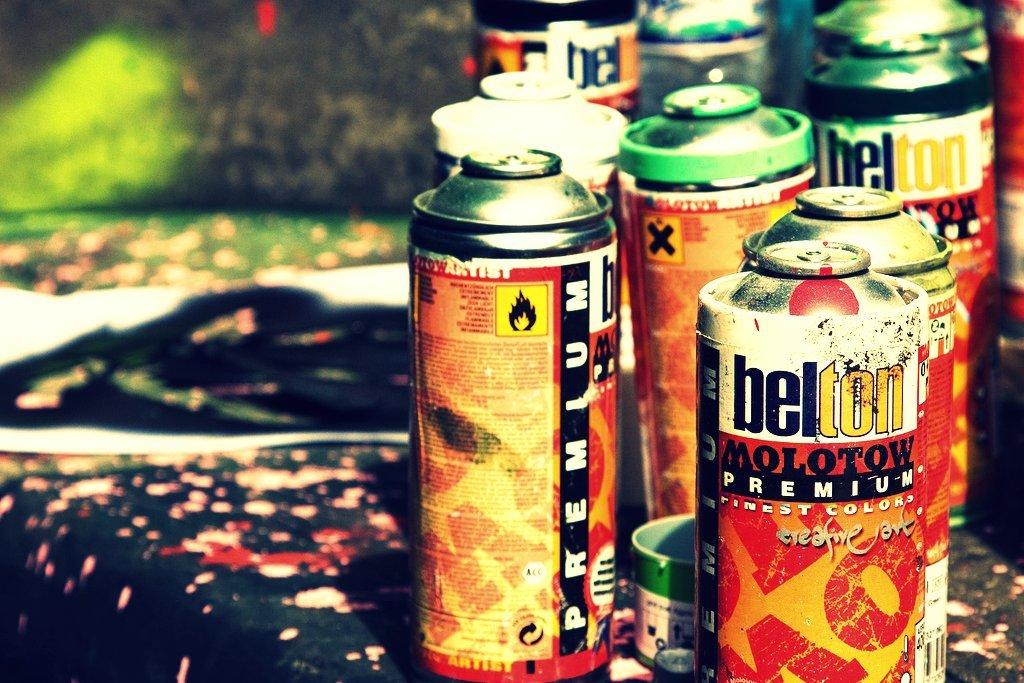What brand of spray paint are these cans?
Provide a short and direct response. Belton. 